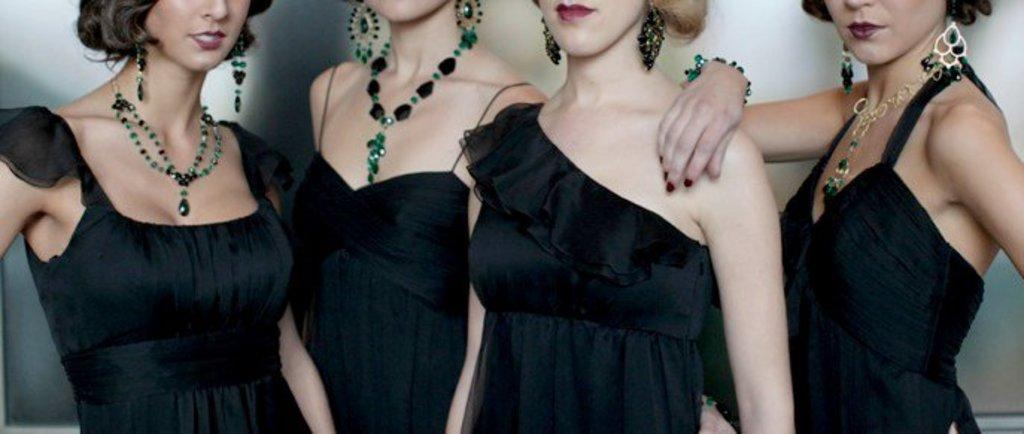How many women are in the image? There are four women in the image. What are the women wearing? The women are wearing black dresses. What are the women doing in the image? The women are standing. What can be seen in the background of the image? There is a wall in the background of the image. What type of smoke can be seen coming from the women's dresses in the image? There is no smoke present in the image; the women are wearing black dresses and standing. How many pigs are visible in the image? There are no pigs present in the image; it features four women wearing black dresses and standing in front of a wall. 